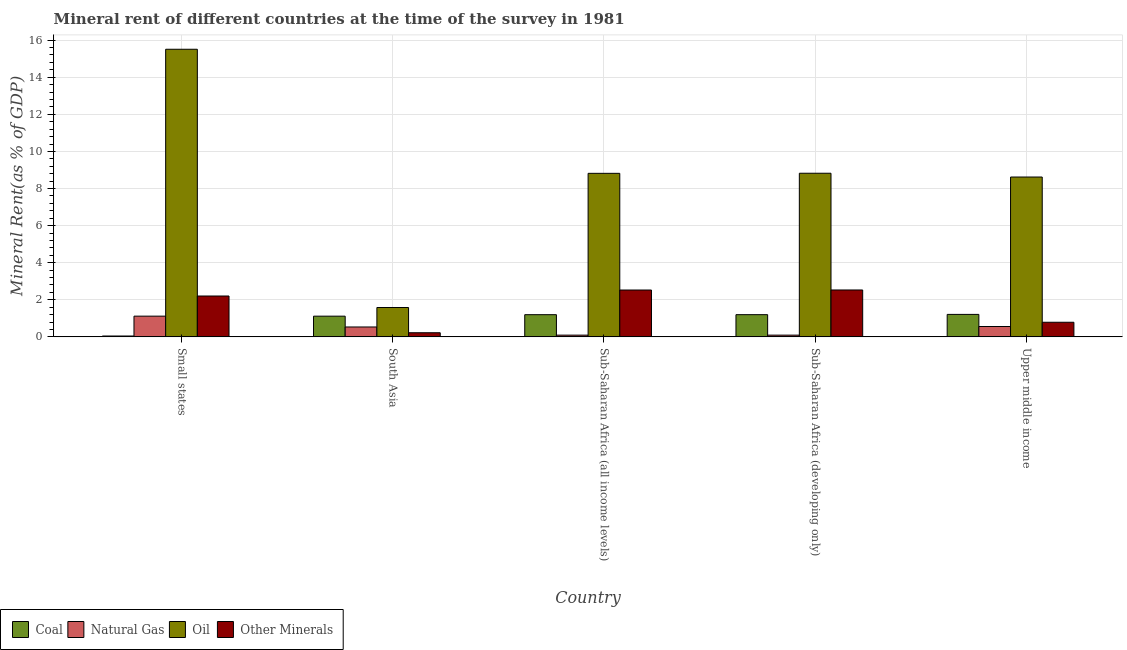How many different coloured bars are there?
Offer a very short reply. 4. How many groups of bars are there?
Your response must be concise. 5. Are the number of bars per tick equal to the number of legend labels?
Make the answer very short. Yes. Are the number of bars on each tick of the X-axis equal?
Offer a very short reply. Yes. How many bars are there on the 4th tick from the left?
Offer a terse response. 4. How many bars are there on the 2nd tick from the right?
Give a very brief answer. 4. What is the label of the 3rd group of bars from the left?
Keep it short and to the point. Sub-Saharan Africa (all income levels). What is the natural gas rent in Small states?
Provide a short and direct response. 1.12. Across all countries, what is the maximum coal rent?
Make the answer very short. 1.21. Across all countries, what is the minimum natural gas rent?
Keep it short and to the point. 0.09. In which country was the coal rent maximum?
Give a very brief answer. Upper middle income. In which country was the natural gas rent minimum?
Your answer should be very brief. Sub-Saharan Africa (all income levels). What is the total oil rent in the graph?
Give a very brief answer. 43.36. What is the difference between the coal rent in South Asia and that in Sub-Saharan Africa (all income levels)?
Ensure brevity in your answer.  -0.08. What is the difference between the oil rent in Sub-Saharan Africa (all income levels) and the coal rent in Sub-Saharan Africa (developing only)?
Provide a short and direct response. 7.62. What is the average coal rent per country?
Provide a short and direct response. 0.95. What is the difference between the  rent of other minerals and natural gas rent in Small states?
Keep it short and to the point. 1.09. In how many countries, is the coal rent greater than 14 %?
Your answer should be very brief. 0. What is the ratio of the natural gas rent in Sub-Saharan Africa (all income levels) to that in Sub-Saharan Africa (developing only)?
Make the answer very short. 1. Is the natural gas rent in Small states less than that in Sub-Saharan Africa (developing only)?
Provide a succinct answer. No. What is the difference between the highest and the second highest natural gas rent?
Make the answer very short. 0.56. What is the difference between the highest and the lowest natural gas rent?
Keep it short and to the point. 1.02. In how many countries, is the oil rent greater than the average oil rent taken over all countries?
Provide a succinct answer. 3. Is the sum of the coal rent in South Asia and Sub-Saharan Africa (all income levels) greater than the maximum  rent of other minerals across all countries?
Offer a very short reply. No. What does the 1st bar from the left in Small states represents?
Your answer should be very brief. Coal. What does the 2nd bar from the right in Sub-Saharan Africa (all income levels) represents?
Your response must be concise. Oil. Is it the case that in every country, the sum of the coal rent and natural gas rent is greater than the oil rent?
Provide a short and direct response. No. How many bars are there?
Offer a very short reply. 20. Are all the bars in the graph horizontal?
Offer a terse response. No. How many countries are there in the graph?
Your answer should be compact. 5. How many legend labels are there?
Ensure brevity in your answer.  4. What is the title of the graph?
Your answer should be compact. Mineral rent of different countries at the time of the survey in 1981. What is the label or title of the X-axis?
Offer a terse response. Country. What is the label or title of the Y-axis?
Your answer should be compact. Mineral Rent(as % of GDP). What is the Mineral Rent(as % of GDP) in Coal in Small states?
Offer a terse response. 0.05. What is the Mineral Rent(as % of GDP) of Natural Gas in Small states?
Provide a succinct answer. 1.12. What is the Mineral Rent(as % of GDP) of Oil in Small states?
Give a very brief answer. 15.51. What is the Mineral Rent(as % of GDP) in Other Minerals in Small states?
Offer a very short reply. 2.2. What is the Mineral Rent(as % of GDP) of Coal in South Asia?
Give a very brief answer. 1.12. What is the Mineral Rent(as % of GDP) of Natural Gas in South Asia?
Give a very brief answer. 0.53. What is the Mineral Rent(as % of GDP) of Oil in South Asia?
Ensure brevity in your answer.  1.58. What is the Mineral Rent(as % of GDP) in Other Minerals in South Asia?
Provide a short and direct response. 0.22. What is the Mineral Rent(as % of GDP) in Coal in Sub-Saharan Africa (all income levels)?
Provide a succinct answer. 1.2. What is the Mineral Rent(as % of GDP) of Natural Gas in Sub-Saharan Africa (all income levels)?
Ensure brevity in your answer.  0.09. What is the Mineral Rent(as % of GDP) of Oil in Sub-Saharan Africa (all income levels)?
Provide a short and direct response. 8.82. What is the Mineral Rent(as % of GDP) of Other Minerals in Sub-Saharan Africa (all income levels)?
Provide a short and direct response. 2.53. What is the Mineral Rent(as % of GDP) in Coal in Sub-Saharan Africa (developing only)?
Offer a terse response. 1.2. What is the Mineral Rent(as % of GDP) in Natural Gas in Sub-Saharan Africa (developing only)?
Give a very brief answer. 0.09. What is the Mineral Rent(as % of GDP) in Oil in Sub-Saharan Africa (developing only)?
Offer a very short reply. 8.82. What is the Mineral Rent(as % of GDP) in Other Minerals in Sub-Saharan Africa (developing only)?
Your answer should be very brief. 2.53. What is the Mineral Rent(as % of GDP) of Coal in Upper middle income?
Your answer should be compact. 1.21. What is the Mineral Rent(as % of GDP) in Natural Gas in Upper middle income?
Offer a very short reply. 0.56. What is the Mineral Rent(as % of GDP) in Oil in Upper middle income?
Ensure brevity in your answer.  8.62. What is the Mineral Rent(as % of GDP) in Other Minerals in Upper middle income?
Your answer should be very brief. 0.79. Across all countries, what is the maximum Mineral Rent(as % of GDP) of Coal?
Your answer should be compact. 1.21. Across all countries, what is the maximum Mineral Rent(as % of GDP) in Natural Gas?
Ensure brevity in your answer.  1.12. Across all countries, what is the maximum Mineral Rent(as % of GDP) in Oil?
Keep it short and to the point. 15.51. Across all countries, what is the maximum Mineral Rent(as % of GDP) of Other Minerals?
Give a very brief answer. 2.53. Across all countries, what is the minimum Mineral Rent(as % of GDP) of Coal?
Your answer should be compact. 0.05. Across all countries, what is the minimum Mineral Rent(as % of GDP) of Natural Gas?
Make the answer very short. 0.09. Across all countries, what is the minimum Mineral Rent(as % of GDP) of Oil?
Your answer should be very brief. 1.58. Across all countries, what is the minimum Mineral Rent(as % of GDP) of Other Minerals?
Provide a short and direct response. 0.22. What is the total Mineral Rent(as % of GDP) of Coal in the graph?
Give a very brief answer. 4.77. What is the total Mineral Rent(as % of GDP) in Natural Gas in the graph?
Your answer should be very brief. 2.4. What is the total Mineral Rent(as % of GDP) of Oil in the graph?
Your answer should be very brief. 43.36. What is the total Mineral Rent(as % of GDP) in Other Minerals in the graph?
Your answer should be very brief. 8.27. What is the difference between the Mineral Rent(as % of GDP) in Coal in Small states and that in South Asia?
Ensure brevity in your answer.  -1.07. What is the difference between the Mineral Rent(as % of GDP) of Natural Gas in Small states and that in South Asia?
Make the answer very short. 0.58. What is the difference between the Mineral Rent(as % of GDP) in Oil in Small states and that in South Asia?
Keep it short and to the point. 13.93. What is the difference between the Mineral Rent(as % of GDP) of Other Minerals in Small states and that in South Asia?
Keep it short and to the point. 1.98. What is the difference between the Mineral Rent(as % of GDP) of Coal in Small states and that in Sub-Saharan Africa (all income levels)?
Provide a short and direct response. -1.15. What is the difference between the Mineral Rent(as % of GDP) of Natural Gas in Small states and that in Sub-Saharan Africa (all income levels)?
Ensure brevity in your answer.  1.02. What is the difference between the Mineral Rent(as % of GDP) of Oil in Small states and that in Sub-Saharan Africa (all income levels)?
Ensure brevity in your answer.  6.69. What is the difference between the Mineral Rent(as % of GDP) in Other Minerals in Small states and that in Sub-Saharan Africa (all income levels)?
Your answer should be very brief. -0.32. What is the difference between the Mineral Rent(as % of GDP) in Coal in Small states and that in Sub-Saharan Africa (developing only)?
Provide a succinct answer. -1.15. What is the difference between the Mineral Rent(as % of GDP) of Natural Gas in Small states and that in Sub-Saharan Africa (developing only)?
Offer a terse response. 1.02. What is the difference between the Mineral Rent(as % of GDP) in Oil in Small states and that in Sub-Saharan Africa (developing only)?
Make the answer very short. 6.69. What is the difference between the Mineral Rent(as % of GDP) in Other Minerals in Small states and that in Sub-Saharan Africa (developing only)?
Offer a very short reply. -0.32. What is the difference between the Mineral Rent(as % of GDP) in Coal in Small states and that in Upper middle income?
Keep it short and to the point. -1.17. What is the difference between the Mineral Rent(as % of GDP) of Natural Gas in Small states and that in Upper middle income?
Provide a short and direct response. 0.56. What is the difference between the Mineral Rent(as % of GDP) in Oil in Small states and that in Upper middle income?
Your answer should be compact. 6.89. What is the difference between the Mineral Rent(as % of GDP) in Other Minerals in Small states and that in Upper middle income?
Ensure brevity in your answer.  1.42. What is the difference between the Mineral Rent(as % of GDP) in Coal in South Asia and that in Sub-Saharan Africa (all income levels)?
Offer a very short reply. -0.08. What is the difference between the Mineral Rent(as % of GDP) of Natural Gas in South Asia and that in Sub-Saharan Africa (all income levels)?
Your answer should be compact. 0.44. What is the difference between the Mineral Rent(as % of GDP) of Oil in South Asia and that in Sub-Saharan Africa (all income levels)?
Your answer should be very brief. -7.23. What is the difference between the Mineral Rent(as % of GDP) of Other Minerals in South Asia and that in Sub-Saharan Africa (all income levels)?
Your answer should be compact. -2.3. What is the difference between the Mineral Rent(as % of GDP) in Coal in South Asia and that in Sub-Saharan Africa (developing only)?
Your answer should be very brief. -0.08. What is the difference between the Mineral Rent(as % of GDP) in Natural Gas in South Asia and that in Sub-Saharan Africa (developing only)?
Your response must be concise. 0.44. What is the difference between the Mineral Rent(as % of GDP) of Oil in South Asia and that in Sub-Saharan Africa (developing only)?
Your answer should be compact. -7.24. What is the difference between the Mineral Rent(as % of GDP) of Other Minerals in South Asia and that in Sub-Saharan Africa (developing only)?
Ensure brevity in your answer.  -2.31. What is the difference between the Mineral Rent(as % of GDP) of Coal in South Asia and that in Upper middle income?
Make the answer very short. -0.1. What is the difference between the Mineral Rent(as % of GDP) in Natural Gas in South Asia and that in Upper middle income?
Ensure brevity in your answer.  -0.03. What is the difference between the Mineral Rent(as % of GDP) of Oil in South Asia and that in Upper middle income?
Ensure brevity in your answer.  -7.04. What is the difference between the Mineral Rent(as % of GDP) of Other Minerals in South Asia and that in Upper middle income?
Keep it short and to the point. -0.57. What is the difference between the Mineral Rent(as % of GDP) in Coal in Sub-Saharan Africa (all income levels) and that in Sub-Saharan Africa (developing only)?
Give a very brief answer. -0. What is the difference between the Mineral Rent(as % of GDP) in Natural Gas in Sub-Saharan Africa (all income levels) and that in Sub-Saharan Africa (developing only)?
Your answer should be very brief. -0. What is the difference between the Mineral Rent(as % of GDP) in Oil in Sub-Saharan Africa (all income levels) and that in Sub-Saharan Africa (developing only)?
Make the answer very short. -0.01. What is the difference between the Mineral Rent(as % of GDP) of Other Minerals in Sub-Saharan Africa (all income levels) and that in Sub-Saharan Africa (developing only)?
Your answer should be compact. -0. What is the difference between the Mineral Rent(as % of GDP) of Coal in Sub-Saharan Africa (all income levels) and that in Upper middle income?
Keep it short and to the point. -0.02. What is the difference between the Mineral Rent(as % of GDP) of Natural Gas in Sub-Saharan Africa (all income levels) and that in Upper middle income?
Your answer should be very brief. -0.46. What is the difference between the Mineral Rent(as % of GDP) in Oil in Sub-Saharan Africa (all income levels) and that in Upper middle income?
Make the answer very short. 0.2. What is the difference between the Mineral Rent(as % of GDP) in Other Minerals in Sub-Saharan Africa (all income levels) and that in Upper middle income?
Offer a very short reply. 1.74. What is the difference between the Mineral Rent(as % of GDP) of Coal in Sub-Saharan Africa (developing only) and that in Upper middle income?
Give a very brief answer. -0.01. What is the difference between the Mineral Rent(as % of GDP) in Natural Gas in Sub-Saharan Africa (developing only) and that in Upper middle income?
Give a very brief answer. -0.46. What is the difference between the Mineral Rent(as % of GDP) in Oil in Sub-Saharan Africa (developing only) and that in Upper middle income?
Provide a short and direct response. 0.2. What is the difference between the Mineral Rent(as % of GDP) in Other Minerals in Sub-Saharan Africa (developing only) and that in Upper middle income?
Offer a very short reply. 1.74. What is the difference between the Mineral Rent(as % of GDP) in Coal in Small states and the Mineral Rent(as % of GDP) in Natural Gas in South Asia?
Your answer should be very brief. -0.49. What is the difference between the Mineral Rent(as % of GDP) in Coal in Small states and the Mineral Rent(as % of GDP) in Oil in South Asia?
Your answer should be compact. -1.54. What is the difference between the Mineral Rent(as % of GDP) in Coal in Small states and the Mineral Rent(as % of GDP) in Other Minerals in South Asia?
Ensure brevity in your answer.  -0.18. What is the difference between the Mineral Rent(as % of GDP) of Natural Gas in Small states and the Mineral Rent(as % of GDP) of Oil in South Asia?
Your answer should be very brief. -0.47. What is the difference between the Mineral Rent(as % of GDP) in Natural Gas in Small states and the Mineral Rent(as % of GDP) in Other Minerals in South Asia?
Give a very brief answer. 0.89. What is the difference between the Mineral Rent(as % of GDP) in Oil in Small states and the Mineral Rent(as % of GDP) in Other Minerals in South Asia?
Your response must be concise. 15.29. What is the difference between the Mineral Rent(as % of GDP) in Coal in Small states and the Mineral Rent(as % of GDP) in Natural Gas in Sub-Saharan Africa (all income levels)?
Offer a very short reply. -0.05. What is the difference between the Mineral Rent(as % of GDP) in Coal in Small states and the Mineral Rent(as % of GDP) in Oil in Sub-Saharan Africa (all income levels)?
Offer a very short reply. -8.77. What is the difference between the Mineral Rent(as % of GDP) in Coal in Small states and the Mineral Rent(as % of GDP) in Other Minerals in Sub-Saharan Africa (all income levels)?
Your answer should be very brief. -2.48. What is the difference between the Mineral Rent(as % of GDP) of Natural Gas in Small states and the Mineral Rent(as % of GDP) of Oil in Sub-Saharan Africa (all income levels)?
Provide a succinct answer. -7.7. What is the difference between the Mineral Rent(as % of GDP) of Natural Gas in Small states and the Mineral Rent(as % of GDP) of Other Minerals in Sub-Saharan Africa (all income levels)?
Give a very brief answer. -1.41. What is the difference between the Mineral Rent(as % of GDP) of Oil in Small states and the Mineral Rent(as % of GDP) of Other Minerals in Sub-Saharan Africa (all income levels)?
Your answer should be very brief. 12.98. What is the difference between the Mineral Rent(as % of GDP) in Coal in Small states and the Mineral Rent(as % of GDP) in Natural Gas in Sub-Saharan Africa (developing only)?
Give a very brief answer. -0.05. What is the difference between the Mineral Rent(as % of GDP) in Coal in Small states and the Mineral Rent(as % of GDP) in Oil in Sub-Saharan Africa (developing only)?
Offer a terse response. -8.78. What is the difference between the Mineral Rent(as % of GDP) of Coal in Small states and the Mineral Rent(as % of GDP) of Other Minerals in Sub-Saharan Africa (developing only)?
Provide a short and direct response. -2.48. What is the difference between the Mineral Rent(as % of GDP) in Natural Gas in Small states and the Mineral Rent(as % of GDP) in Oil in Sub-Saharan Africa (developing only)?
Offer a very short reply. -7.71. What is the difference between the Mineral Rent(as % of GDP) in Natural Gas in Small states and the Mineral Rent(as % of GDP) in Other Minerals in Sub-Saharan Africa (developing only)?
Make the answer very short. -1.41. What is the difference between the Mineral Rent(as % of GDP) in Oil in Small states and the Mineral Rent(as % of GDP) in Other Minerals in Sub-Saharan Africa (developing only)?
Give a very brief answer. 12.98. What is the difference between the Mineral Rent(as % of GDP) of Coal in Small states and the Mineral Rent(as % of GDP) of Natural Gas in Upper middle income?
Your answer should be compact. -0.51. What is the difference between the Mineral Rent(as % of GDP) in Coal in Small states and the Mineral Rent(as % of GDP) in Oil in Upper middle income?
Make the answer very short. -8.57. What is the difference between the Mineral Rent(as % of GDP) in Coal in Small states and the Mineral Rent(as % of GDP) in Other Minerals in Upper middle income?
Your response must be concise. -0.74. What is the difference between the Mineral Rent(as % of GDP) in Natural Gas in Small states and the Mineral Rent(as % of GDP) in Oil in Upper middle income?
Give a very brief answer. -7.5. What is the difference between the Mineral Rent(as % of GDP) in Natural Gas in Small states and the Mineral Rent(as % of GDP) in Other Minerals in Upper middle income?
Ensure brevity in your answer.  0.33. What is the difference between the Mineral Rent(as % of GDP) in Oil in Small states and the Mineral Rent(as % of GDP) in Other Minerals in Upper middle income?
Give a very brief answer. 14.72. What is the difference between the Mineral Rent(as % of GDP) in Coal in South Asia and the Mineral Rent(as % of GDP) in Natural Gas in Sub-Saharan Africa (all income levels)?
Offer a terse response. 1.02. What is the difference between the Mineral Rent(as % of GDP) of Coal in South Asia and the Mineral Rent(as % of GDP) of Oil in Sub-Saharan Africa (all income levels)?
Give a very brief answer. -7.7. What is the difference between the Mineral Rent(as % of GDP) in Coal in South Asia and the Mineral Rent(as % of GDP) in Other Minerals in Sub-Saharan Africa (all income levels)?
Your answer should be very brief. -1.41. What is the difference between the Mineral Rent(as % of GDP) in Natural Gas in South Asia and the Mineral Rent(as % of GDP) in Oil in Sub-Saharan Africa (all income levels)?
Ensure brevity in your answer.  -8.29. What is the difference between the Mineral Rent(as % of GDP) in Natural Gas in South Asia and the Mineral Rent(as % of GDP) in Other Minerals in Sub-Saharan Africa (all income levels)?
Provide a succinct answer. -1.99. What is the difference between the Mineral Rent(as % of GDP) of Oil in South Asia and the Mineral Rent(as % of GDP) of Other Minerals in Sub-Saharan Africa (all income levels)?
Ensure brevity in your answer.  -0.94. What is the difference between the Mineral Rent(as % of GDP) of Coal in South Asia and the Mineral Rent(as % of GDP) of Natural Gas in Sub-Saharan Africa (developing only)?
Your answer should be very brief. 1.02. What is the difference between the Mineral Rent(as % of GDP) of Coal in South Asia and the Mineral Rent(as % of GDP) of Oil in Sub-Saharan Africa (developing only)?
Offer a very short reply. -7.71. What is the difference between the Mineral Rent(as % of GDP) of Coal in South Asia and the Mineral Rent(as % of GDP) of Other Minerals in Sub-Saharan Africa (developing only)?
Your answer should be very brief. -1.41. What is the difference between the Mineral Rent(as % of GDP) of Natural Gas in South Asia and the Mineral Rent(as % of GDP) of Oil in Sub-Saharan Africa (developing only)?
Offer a terse response. -8.29. What is the difference between the Mineral Rent(as % of GDP) of Natural Gas in South Asia and the Mineral Rent(as % of GDP) of Other Minerals in Sub-Saharan Africa (developing only)?
Your response must be concise. -2. What is the difference between the Mineral Rent(as % of GDP) of Oil in South Asia and the Mineral Rent(as % of GDP) of Other Minerals in Sub-Saharan Africa (developing only)?
Offer a terse response. -0.95. What is the difference between the Mineral Rent(as % of GDP) of Coal in South Asia and the Mineral Rent(as % of GDP) of Natural Gas in Upper middle income?
Your answer should be compact. 0.56. What is the difference between the Mineral Rent(as % of GDP) in Coal in South Asia and the Mineral Rent(as % of GDP) in Oil in Upper middle income?
Keep it short and to the point. -7.5. What is the difference between the Mineral Rent(as % of GDP) of Coal in South Asia and the Mineral Rent(as % of GDP) of Other Minerals in Upper middle income?
Your answer should be very brief. 0.33. What is the difference between the Mineral Rent(as % of GDP) in Natural Gas in South Asia and the Mineral Rent(as % of GDP) in Oil in Upper middle income?
Your response must be concise. -8.09. What is the difference between the Mineral Rent(as % of GDP) in Natural Gas in South Asia and the Mineral Rent(as % of GDP) in Other Minerals in Upper middle income?
Make the answer very short. -0.26. What is the difference between the Mineral Rent(as % of GDP) of Oil in South Asia and the Mineral Rent(as % of GDP) of Other Minerals in Upper middle income?
Offer a terse response. 0.8. What is the difference between the Mineral Rent(as % of GDP) in Coal in Sub-Saharan Africa (all income levels) and the Mineral Rent(as % of GDP) in Natural Gas in Sub-Saharan Africa (developing only)?
Give a very brief answer. 1.1. What is the difference between the Mineral Rent(as % of GDP) of Coal in Sub-Saharan Africa (all income levels) and the Mineral Rent(as % of GDP) of Oil in Sub-Saharan Africa (developing only)?
Offer a terse response. -7.63. What is the difference between the Mineral Rent(as % of GDP) in Coal in Sub-Saharan Africa (all income levels) and the Mineral Rent(as % of GDP) in Other Minerals in Sub-Saharan Africa (developing only)?
Ensure brevity in your answer.  -1.33. What is the difference between the Mineral Rent(as % of GDP) in Natural Gas in Sub-Saharan Africa (all income levels) and the Mineral Rent(as % of GDP) in Oil in Sub-Saharan Africa (developing only)?
Ensure brevity in your answer.  -8.73. What is the difference between the Mineral Rent(as % of GDP) of Natural Gas in Sub-Saharan Africa (all income levels) and the Mineral Rent(as % of GDP) of Other Minerals in Sub-Saharan Africa (developing only)?
Give a very brief answer. -2.43. What is the difference between the Mineral Rent(as % of GDP) of Oil in Sub-Saharan Africa (all income levels) and the Mineral Rent(as % of GDP) of Other Minerals in Sub-Saharan Africa (developing only)?
Offer a very short reply. 6.29. What is the difference between the Mineral Rent(as % of GDP) of Coal in Sub-Saharan Africa (all income levels) and the Mineral Rent(as % of GDP) of Natural Gas in Upper middle income?
Provide a short and direct response. 0.64. What is the difference between the Mineral Rent(as % of GDP) of Coal in Sub-Saharan Africa (all income levels) and the Mineral Rent(as % of GDP) of Oil in Upper middle income?
Offer a very short reply. -7.42. What is the difference between the Mineral Rent(as % of GDP) in Coal in Sub-Saharan Africa (all income levels) and the Mineral Rent(as % of GDP) in Other Minerals in Upper middle income?
Offer a very short reply. 0.41. What is the difference between the Mineral Rent(as % of GDP) of Natural Gas in Sub-Saharan Africa (all income levels) and the Mineral Rent(as % of GDP) of Oil in Upper middle income?
Provide a short and direct response. -8.53. What is the difference between the Mineral Rent(as % of GDP) in Natural Gas in Sub-Saharan Africa (all income levels) and the Mineral Rent(as % of GDP) in Other Minerals in Upper middle income?
Offer a terse response. -0.69. What is the difference between the Mineral Rent(as % of GDP) of Oil in Sub-Saharan Africa (all income levels) and the Mineral Rent(as % of GDP) of Other Minerals in Upper middle income?
Your response must be concise. 8.03. What is the difference between the Mineral Rent(as % of GDP) of Coal in Sub-Saharan Africa (developing only) and the Mineral Rent(as % of GDP) of Natural Gas in Upper middle income?
Ensure brevity in your answer.  0.64. What is the difference between the Mineral Rent(as % of GDP) of Coal in Sub-Saharan Africa (developing only) and the Mineral Rent(as % of GDP) of Oil in Upper middle income?
Your answer should be very brief. -7.42. What is the difference between the Mineral Rent(as % of GDP) in Coal in Sub-Saharan Africa (developing only) and the Mineral Rent(as % of GDP) in Other Minerals in Upper middle income?
Your answer should be compact. 0.41. What is the difference between the Mineral Rent(as % of GDP) in Natural Gas in Sub-Saharan Africa (developing only) and the Mineral Rent(as % of GDP) in Oil in Upper middle income?
Keep it short and to the point. -8.53. What is the difference between the Mineral Rent(as % of GDP) of Natural Gas in Sub-Saharan Africa (developing only) and the Mineral Rent(as % of GDP) of Other Minerals in Upper middle income?
Offer a very short reply. -0.69. What is the difference between the Mineral Rent(as % of GDP) of Oil in Sub-Saharan Africa (developing only) and the Mineral Rent(as % of GDP) of Other Minerals in Upper middle income?
Your answer should be compact. 8.04. What is the average Mineral Rent(as % of GDP) in Coal per country?
Provide a short and direct response. 0.95. What is the average Mineral Rent(as % of GDP) of Natural Gas per country?
Your answer should be compact. 0.48. What is the average Mineral Rent(as % of GDP) in Oil per country?
Offer a very short reply. 8.67. What is the average Mineral Rent(as % of GDP) in Other Minerals per country?
Give a very brief answer. 1.65. What is the difference between the Mineral Rent(as % of GDP) in Coal and Mineral Rent(as % of GDP) in Natural Gas in Small states?
Your answer should be compact. -1.07. What is the difference between the Mineral Rent(as % of GDP) in Coal and Mineral Rent(as % of GDP) in Oil in Small states?
Offer a terse response. -15.46. What is the difference between the Mineral Rent(as % of GDP) in Coal and Mineral Rent(as % of GDP) in Other Minerals in Small states?
Your response must be concise. -2.16. What is the difference between the Mineral Rent(as % of GDP) of Natural Gas and Mineral Rent(as % of GDP) of Oil in Small states?
Give a very brief answer. -14.39. What is the difference between the Mineral Rent(as % of GDP) in Natural Gas and Mineral Rent(as % of GDP) in Other Minerals in Small states?
Offer a terse response. -1.09. What is the difference between the Mineral Rent(as % of GDP) of Oil and Mineral Rent(as % of GDP) of Other Minerals in Small states?
Keep it short and to the point. 13.31. What is the difference between the Mineral Rent(as % of GDP) of Coal and Mineral Rent(as % of GDP) of Natural Gas in South Asia?
Offer a very short reply. 0.58. What is the difference between the Mineral Rent(as % of GDP) of Coal and Mineral Rent(as % of GDP) of Oil in South Asia?
Give a very brief answer. -0.47. What is the difference between the Mineral Rent(as % of GDP) in Coal and Mineral Rent(as % of GDP) in Other Minerals in South Asia?
Ensure brevity in your answer.  0.89. What is the difference between the Mineral Rent(as % of GDP) in Natural Gas and Mineral Rent(as % of GDP) in Oil in South Asia?
Your answer should be very brief. -1.05. What is the difference between the Mineral Rent(as % of GDP) in Natural Gas and Mineral Rent(as % of GDP) in Other Minerals in South Asia?
Provide a succinct answer. 0.31. What is the difference between the Mineral Rent(as % of GDP) of Oil and Mineral Rent(as % of GDP) of Other Minerals in South Asia?
Offer a terse response. 1.36. What is the difference between the Mineral Rent(as % of GDP) in Coal and Mineral Rent(as % of GDP) in Natural Gas in Sub-Saharan Africa (all income levels)?
Provide a succinct answer. 1.1. What is the difference between the Mineral Rent(as % of GDP) in Coal and Mineral Rent(as % of GDP) in Oil in Sub-Saharan Africa (all income levels)?
Make the answer very short. -7.62. What is the difference between the Mineral Rent(as % of GDP) in Coal and Mineral Rent(as % of GDP) in Other Minerals in Sub-Saharan Africa (all income levels)?
Your answer should be very brief. -1.33. What is the difference between the Mineral Rent(as % of GDP) of Natural Gas and Mineral Rent(as % of GDP) of Oil in Sub-Saharan Africa (all income levels)?
Make the answer very short. -8.72. What is the difference between the Mineral Rent(as % of GDP) in Natural Gas and Mineral Rent(as % of GDP) in Other Minerals in Sub-Saharan Africa (all income levels)?
Your answer should be compact. -2.43. What is the difference between the Mineral Rent(as % of GDP) of Oil and Mineral Rent(as % of GDP) of Other Minerals in Sub-Saharan Africa (all income levels)?
Your answer should be very brief. 6.29. What is the difference between the Mineral Rent(as % of GDP) in Coal and Mineral Rent(as % of GDP) in Natural Gas in Sub-Saharan Africa (developing only)?
Your response must be concise. 1.1. What is the difference between the Mineral Rent(as % of GDP) in Coal and Mineral Rent(as % of GDP) in Oil in Sub-Saharan Africa (developing only)?
Offer a terse response. -7.63. What is the difference between the Mineral Rent(as % of GDP) in Coal and Mineral Rent(as % of GDP) in Other Minerals in Sub-Saharan Africa (developing only)?
Your response must be concise. -1.33. What is the difference between the Mineral Rent(as % of GDP) of Natural Gas and Mineral Rent(as % of GDP) of Oil in Sub-Saharan Africa (developing only)?
Offer a terse response. -8.73. What is the difference between the Mineral Rent(as % of GDP) of Natural Gas and Mineral Rent(as % of GDP) of Other Minerals in Sub-Saharan Africa (developing only)?
Provide a succinct answer. -2.43. What is the difference between the Mineral Rent(as % of GDP) of Oil and Mineral Rent(as % of GDP) of Other Minerals in Sub-Saharan Africa (developing only)?
Make the answer very short. 6.3. What is the difference between the Mineral Rent(as % of GDP) of Coal and Mineral Rent(as % of GDP) of Natural Gas in Upper middle income?
Your response must be concise. 0.65. What is the difference between the Mineral Rent(as % of GDP) in Coal and Mineral Rent(as % of GDP) in Oil in Upper middle income?
Keep it short and to the point. -7.41. What is the difference between the Mineral Rent(as % of GDP) in Coal and Mineral Rent(as % of GDP) in Other Minerals in Upper middle income?
Provide a short and direct response. 0.42. What is the difference between the Mineral Rent(as % of GDP) of Natural Gas and Mineral Rent(as % of GDP) of Oil in Upper middle income?
Give a very brief answer. -8.06. What is the difference between the Mineral Rent(as % of GDP) of Natural Gas and Mineral Rent(as % of GDP) of Other Minerals in Upper middle income?
Offer a terse response. -0.23. What is the difference between the Mineral Rent(as % of GDP) of Oil and Mineral Rent(as % of GDP) of Other Minerals in Upper middle income?
Provide a succinct answer. 7.83. What is the ratio of the Mineral Rent(as % of GDP) of Coal in Small states to that in South Asia?
Ensure brevity in your answer.  0.04. What is the ratio of the Mineral Rent(as % of GDP) in Natural Gas in Small states to that in South Asia?
Provide a succinct answer. 2.1. What is the ratio of the Mineral Rent(as % of GDP) in Oil in Small states to that in South Asia?
Your answer should be compact. 9.79. What is the ratio of the Mineral Rent(as % of GDP) in Other Minerals in Small states to that in South Asia?
Offer a very short reply. 9.89. What is the ratio of the Mineral Rent(as % of GDP) in Coal in Small states to that in Sub-Saharan Africa (all income levels)?
Ensure brevity in your answer.  0.04. What is the ratio of the Mineral Rent(as % of GDP) of Natural Gas in Small states to that in Sub-Saharan Africa (all income levels)?
Your response must be concise. 11.89. What is the ratio of the Mineral Rent(as % of GDP) in Oil in Small states to that in Sub-Saharan Africa (all income levels)?
Your response must be concise. 1.76. What is the ratio of the Mineral Rent(as % of GDP) in Other Minerals in Small states to that in Sub-Saharan Africa (all income levels)?
Give a very brief answer. 0.87. What is the ratio of the Mineral Rent(as % of GDP) of Coal in Small states to that in Sub-Saharan Africa (developing only)?
Ensure brevity in your answer.  0.04. What is the ratio of the Mineral Rent(as % of GDP) in Natural Gas in Small states to that in Sub-Saharan Africa (developing only)?
Provide a short and direct response. 11.89. What is the ratio of the Mineral Rent(as % of GDP) of Oil in Small states to that in Sub-Saharan Africa (developing only)?
Keep it short and to the point. 1.76. What is the ratio of the Mineral Rent(as % of GDP) in Other Minerals in Small states to that in Sub-Saharan Africa (developing only)?
Your answer should be compact. 0.87. What is the ratio of the Mineral Rent(as % of GDP) of Coal in Small states to that in Upper middle income?
Keep it short and to the point. 0.04. What is the ratio of the Mineral Rent(as % of GDP) of Natural Gas in Small states to that in Upper middle income?
Ensure brevity in your answer.  2. What is the ratio of the Mineral Rent(as % of GDP) of Oil in Small states to that in Upper middle income?
Keep it short and to the point. 1.8. What is the ratio of the Mineral Rent(as % of GDP) in Other Minerals in Small states to that in Upper middle income?
Your answer should be compact. 2.8. What is the ratio of the Mineral Rent(as % of GDP) of Coal in South Asia to that in Sub-Saharan Africa (all income levels)?
Your answer should be very brief. 0.93. What is the ratio of the Mineral Rent(as % of GDP) of Natural Gas in South Asia to that in Sub-Saharan Africa (all income levels)?
Make the answer very short. 5.68. What is the ratio of the Mineral Rent(as % of GDP) in Oil in South Asia to that in Sub-Saharan Africa (all income levels)?
Your answer should be very brief. 0.18. What is the ratio of the Mineral Rent(as % of GDP) of Other Minerals in South Asia to that in Sub-Saharan Africa (all income levels)?
Ensure brevity in your answer.  0.09. What is the ratio of the Mineral Rent(as % of GDP) in Coal in South Asia to that in Sub-Saharan Africa (developing only)?
Make the answer very short. 0.93. What is the ratio of the Mineral Rent(as % of GDP) of Natural Gas in South Asia to that in Sub-Saharan Africa (developing only)?
Offer a terse response. 5.67. What is the ratio of the Mineral Rent(as % of GDP) of Oil in South Asia to that in Sub-Saharan Africa (developing only)?
Provide a short and direct response. 0.18. What is the ratio of the Mineral Rent(as % of GDP) of Other Minerals in South Asia to that in Sub-Saharan Africa (developing only)?
Keep it short and to the point. 0.09. What is the ratio of the Mineral Rent(as % of GDP) of Coal in South Asia to that in Upper middle income?
Ensure brevity in your answer.  0.92. What is the ratio of the Mineral Rent(as % of GDP) in Natural Gas in South Asia to that in Upper middle income?
Give a very brief answer. 0.95. What is the ratio of the Mineral Rent(as % of GDP) of Oil in South Asia to that in Upper middle income?
Your answer should be compact. 0.18. What is the ratio of the Mineral Rent(as % of GDP) of Other Minerals in South Asia to that in Upper middle income?
Make the answer very short. 0.28. What is the ratio of the Mineral Rent(as % of GDP) in Oil in Sub-Saharan Africa (all income levels) to that in Sub-Saharan Africa (developing only)?
Give a very brief answer. 1. What is the ratio of the Mineral Rent(as % of GDP) of Coal in Sub-Saharan Africa (all income levels) to that in Upper middle income?
Keep it short and to the point. 0.99. What is the ratio of the Mineral Rent(as % of GDP) of Natural Gas in Sub-Saharan Africa (all income levels) to that in Upper middle income?
Make the answer very short. 0.17. What is the ratio of the Mineral Rent(as % of GDP) in Other Minerals in Sub-Saharan Africa (all income levels) to that in Upper middle income?
Your answer should be very brief. 3.2. What is the ratio of the Mineral Rent(as % of GDP) in Coal in Sub-Saharan Africa (developing only) to that in Upper middle income?
Your answer should be very brief. 0.99. What is the ratio of the Mineral Rent(as % of GDP) in Natural Gas in Sub-Saharan Africa (developing only) to that in Upper middle income?
Provide a succinct answer. 0.17. What is the ratio of the Mineral Rent(as % of GDP) of Oil in Sub-Saharan Africa (developing only) to that in Upper middle income?
Keep it short and to the point. 1.02. What is the ratio of the Mineral Rent(as % of GDP) in Other Minerals in Sub-Saharan Africa (developing only) to that in Upper middle income?
Ensure brevity in your answer.  3.21. What is the difference between the highest and the second highest Mineral Rent(as % of GDP) in Coal?
Ensure brevity in your answer.  0.01. What is the difference between the highest and the second highest Mineral Rent(as % of GDP) of Natural Gas?
Offer a terse response. 0.56. What is the difference between the highest and the second highest Mineral Rent(as % of GDP) of Oil?
Provide a short and direct response. 6.69. What is the difference between the highest and the second highest Mineral Rent(as % of GDP) in Other Minerals?
Make the answer very short. 0. What is the difference between the highest and the lowest Mineral Rent(as % of GDP) in Coal?
Ensure brevity in your answer.  1.17. What is the difference between the highest and the lowest Mineral Rent(as % of GDP) in Natural Gas?
Your answer should be very brief. 1.02. What is the difference between the highest and the lowest Mineral Rent(as % of GDP) of Oil?
Provide a short and direct response. 13.93. What is the difference between the highest and the lowest Mineral Rent(as % of GDP) of Other Minerals?
Make the answer very short. 2.31. 